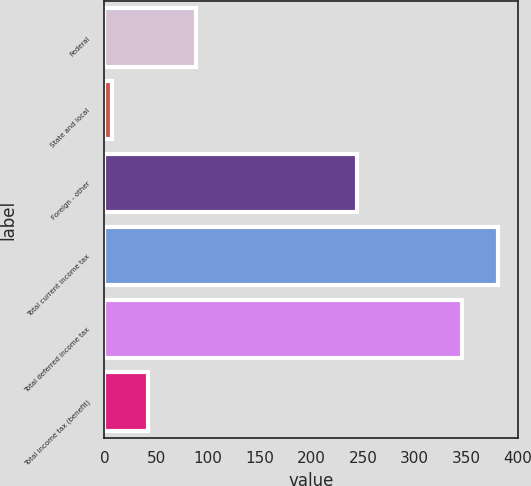<chart> <loc_0><loc_0><loc_500><loc_500><bar_chart><fcel>Federal<fcel>State and local<fcel>Foreign - other<fcel>Total current income tax<fcel>Total deferred income tax<fcel>Total income tax (benefit)<nl><fcel>89<fcel>7<fcel>244<fcel>381<fcel>346<fcel>42<nl></chart> 